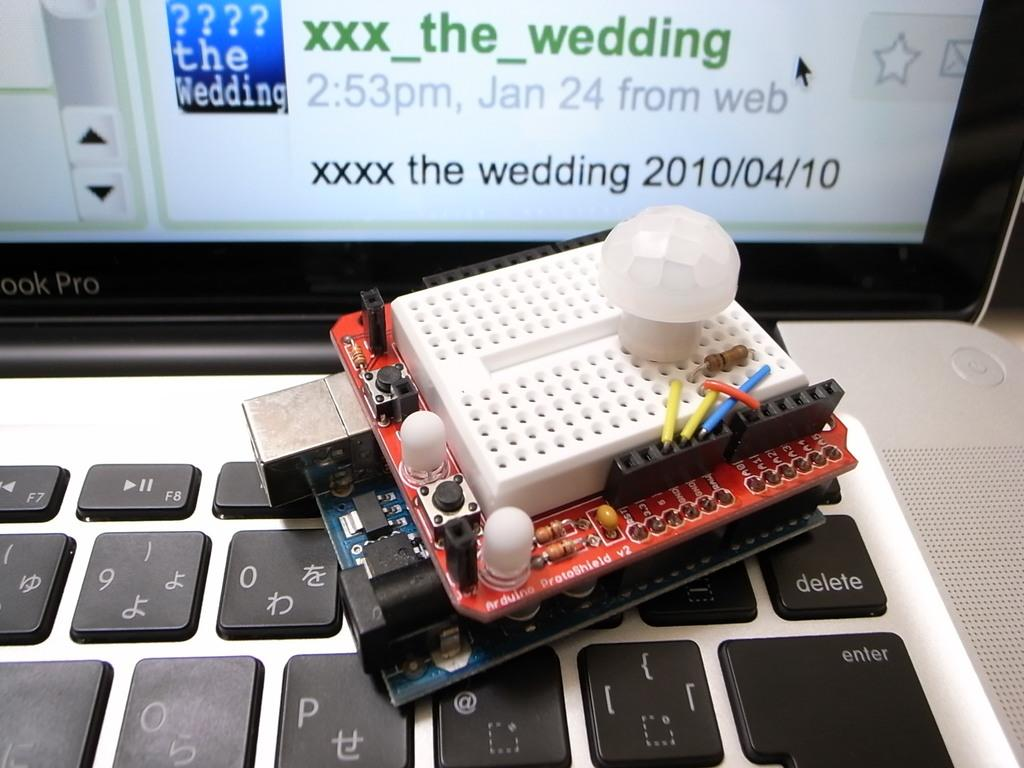Provide a one-sentence caption for the provided image. A circuit board sits on a keyboard in front of a screen promotiong the wedding on April 10, 2010. 